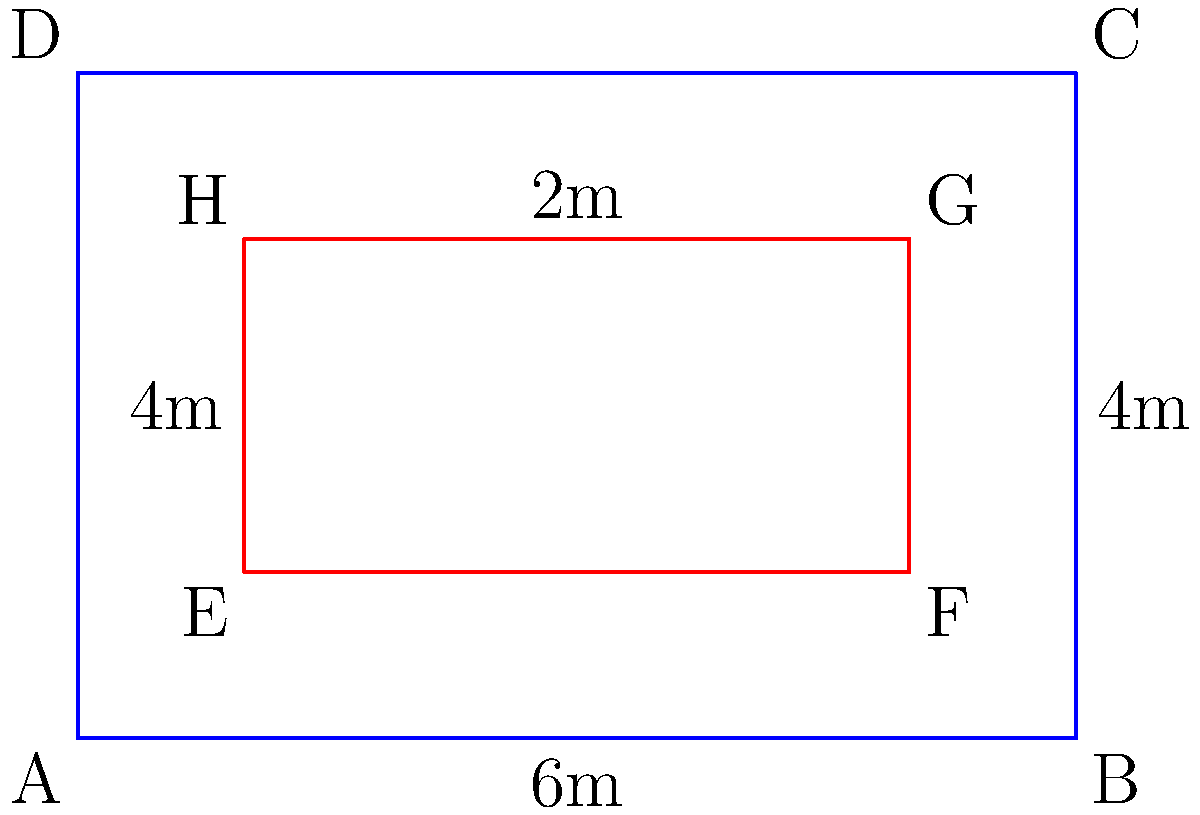As an aspiring rower preparing for your first regatta at the National Rowing Centre in Cork, you're studying different rowing course layouts. The blue rectangle ABCD represents a standard 6-lane course, while the red rectangle EFGH represents a 4-lane course. If both rectangles are congruent, what is the length of the 4-lane course (EF) in meters? To determine if the rectangles are congruent and find the length of EF, let's follow these steps:

1) For rectangles to be congruent, they must have the same shape and size. This means their corresponding sides must be equal, and their areas must be the same.

2) We know the dimensions of rectangle ABCD:
   Length (AB) = 6m
   Width (AD) = 4m
   Area of ABCD = 6m × 4m = 24m²

3) For rectangle EFGH:
   Width (EH) = 2m (given in the diagram)
   Area must be 24m² if congruent to ABCD

4) To find the length of EF, we can use the area formula:
   Area = Length × Width
   24 = EF × 2

5) Solving for EF:
   EF = 24 ÷ 2 = 12m

6) Check for congruence:
   ABCD: 6m × 4m = 24m²
   EFGH: 12m × 2m = 24m²

   The areas are equal, confirming that the rectangles are indeed congruent.

Therefore, the length of the 4-lane course (EF) is 12 meters.
Answer: 12 meters 